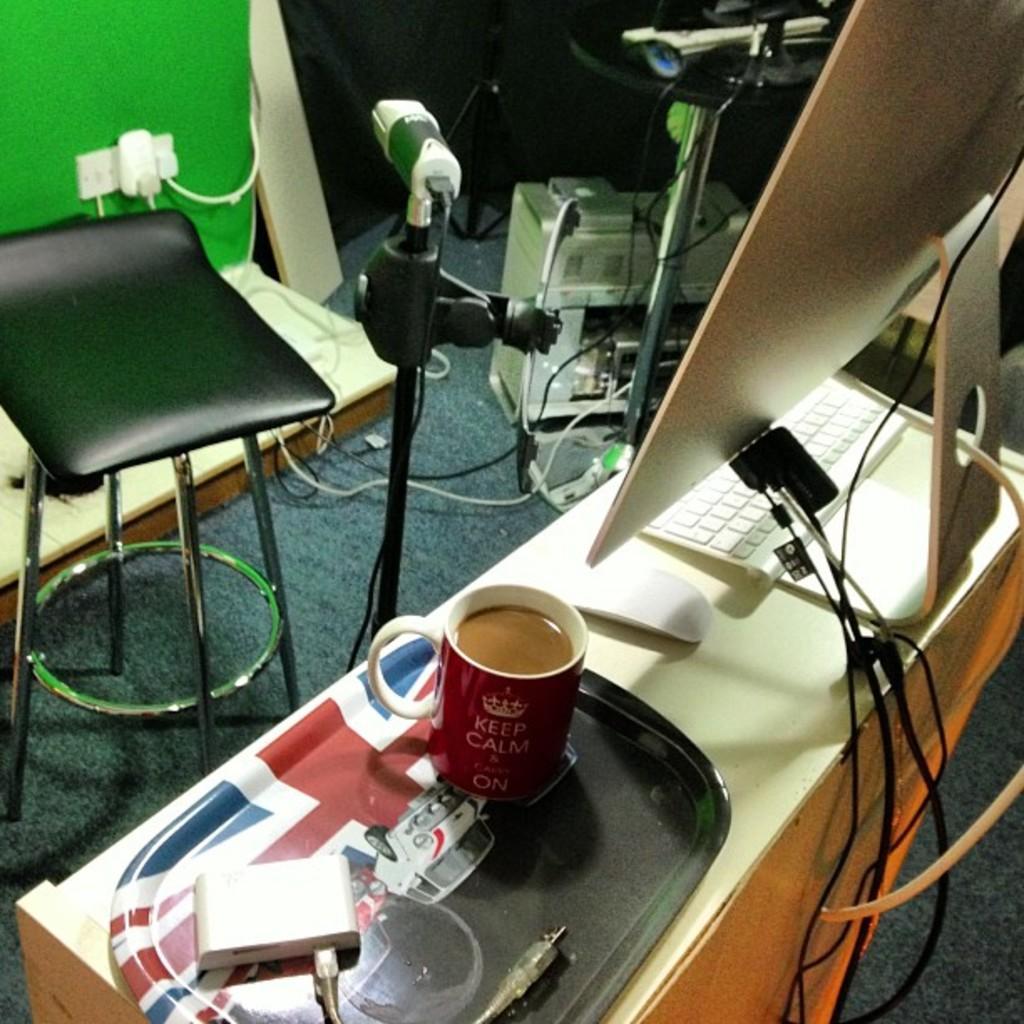Could you give a brief overview of what you see in this image? In this picture, we see many electrical equipment. On left bottom, we see black stool and beside that, we see a bed which is white in color and on right bottom, we see monitor and keyboard which are placed on the table and on left corner of picture, we see green wall. 